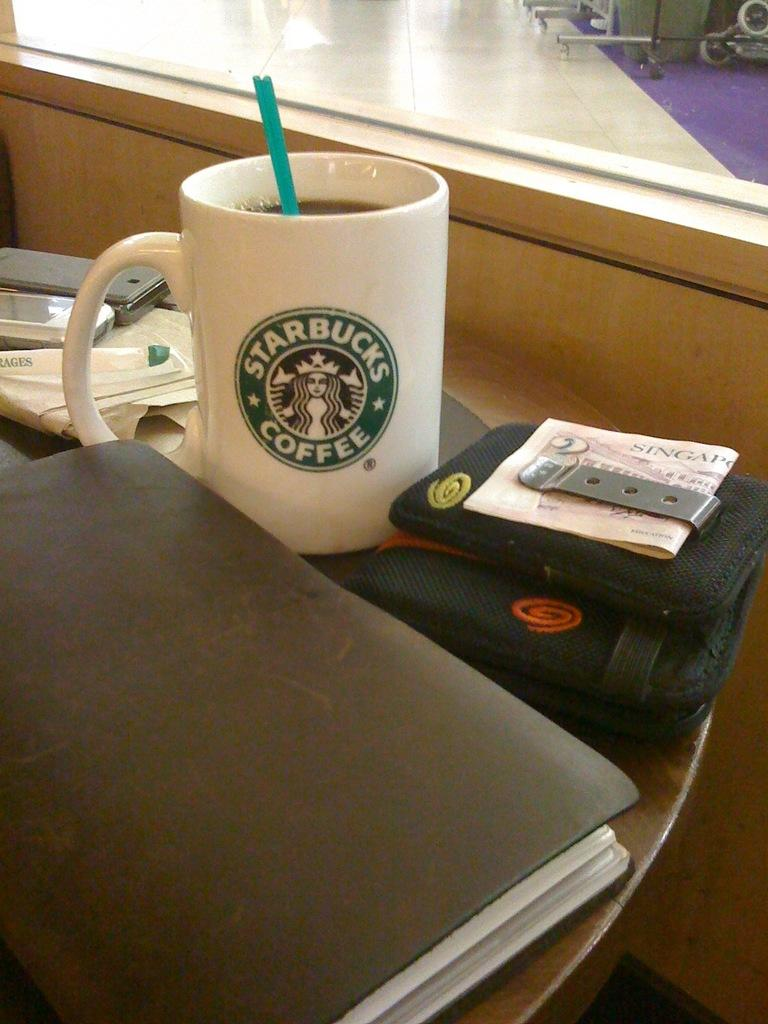What is the main object visible in the image? There is a cup in the image. What is written on the cup? The cup has "Starbucks Coffee" written on it. What else can be seen on the table in the image? There are additional items on the table in the image. What hobbies are people engaging in at the town's zoo in the image? There is no information about hobbies, a town, or a zoo in the image. The image only features a cup with "Starbucks Coffee" written on it and additional items on a table. 